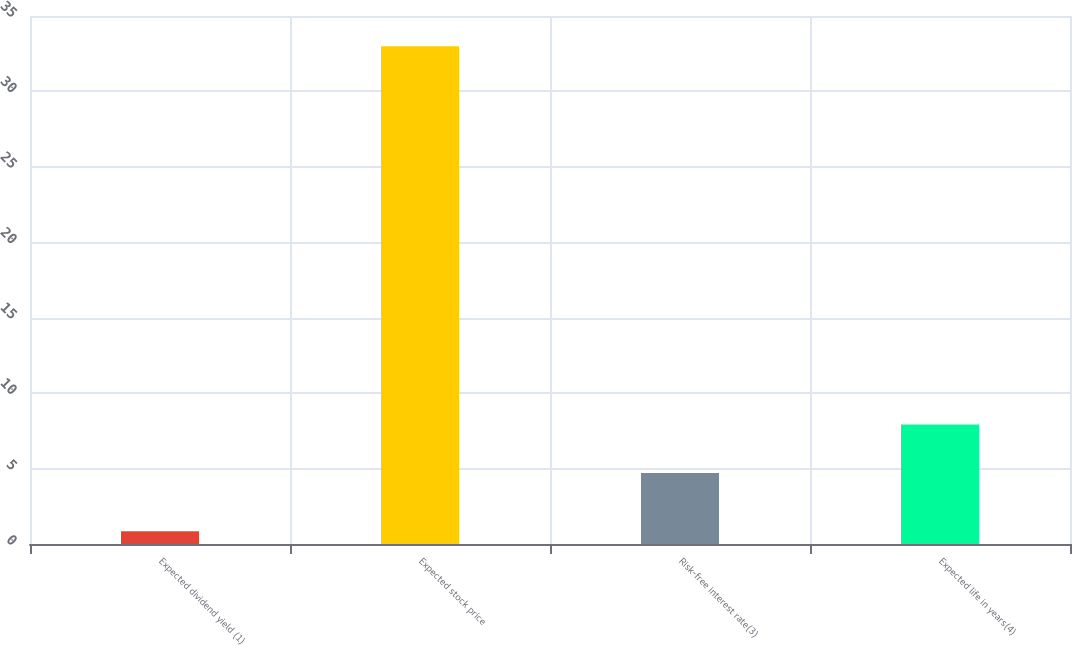Convert chart. <chart><loc_0><loc_0><loc_500><loc_500><bar_chart><fcel>Expected dividend yield (1)<fcel>Expected stock price<fcel>Risk-free interest rate(3)<fcel>Expected life in years(4)<nl><fcel>0.85<fcel>33<fcel>4.7<fcel>7.92<nl></chart> 